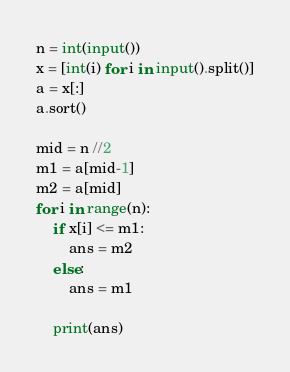<code> <loc_0><loc_0><loc_500><loc_500><_Python_>n = int(input())
x = [int(i) for i in input().split()]
a = x[:]
a.sort()

mid = n //2
m1 = a[mid-1]
m2 = a[mid]
for i in range(n):
    if x[i] <= m1:
        ans = m2
    else:
        ans = m1
 
    print(ans)</code> 